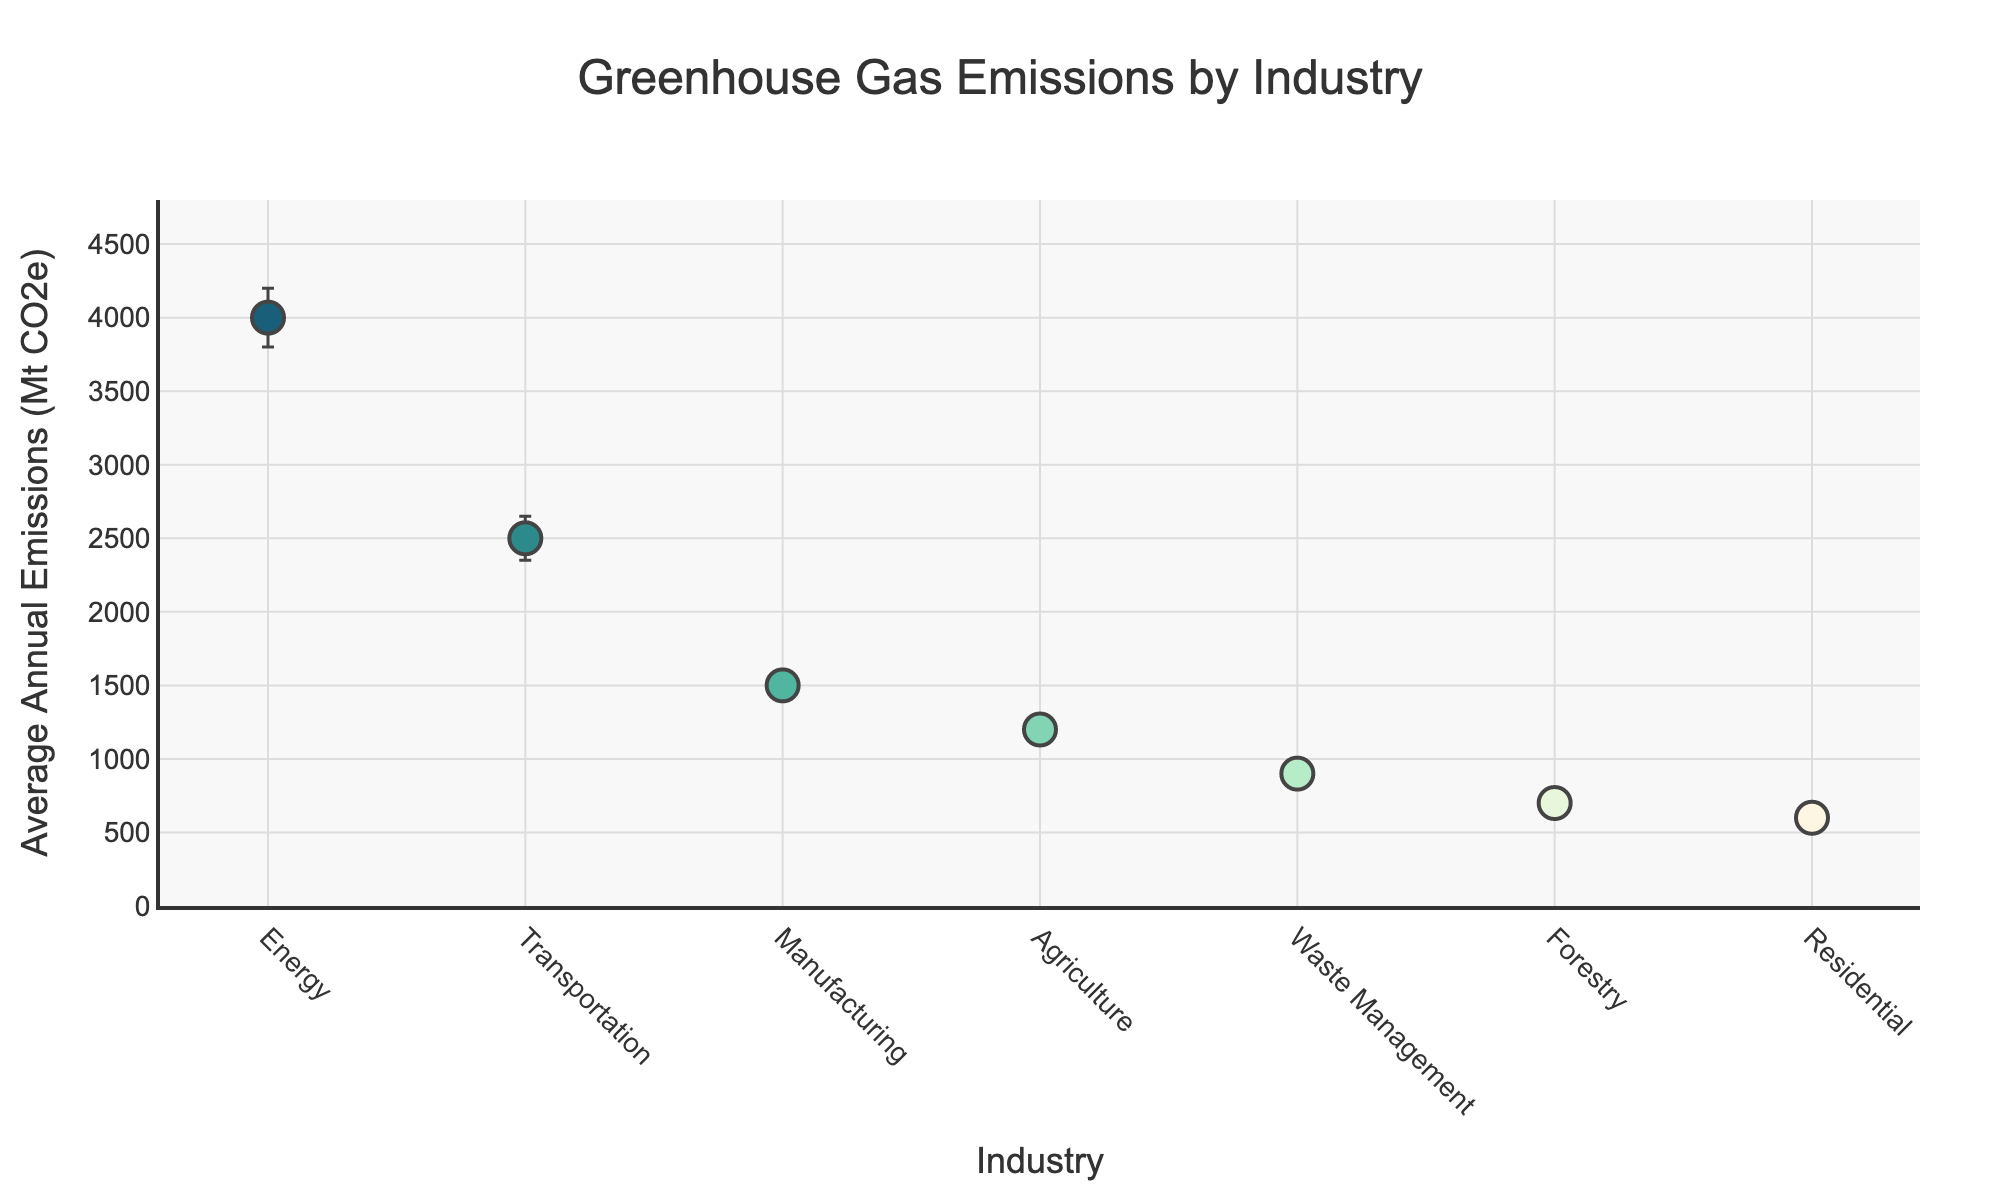What's the title of the figure? The title is displayed prominently at the top of the figure. It summarizes the main content of the plot.
Answer: Greenhouse Gas Emissions by Industry How many industries are represented in the figure? Each data point represents an industry. Counting the points displayed yields the total number of industries.
Answer: 7 Which industry has the highest average annual emissions? The y-axis represents average annual emissions, and the highest data point on this axis indicates the industry with the highest emissions.
Answer: Energy Which industry has the smallest annual fluctuation margin in emissions? The error bars indicate the fluctuation margins. The shortest error bar corresponds to the smallest fluctuation margin.
Answer: Residential What is the range of average annual emissions among the industries? The range is calculated by subtracting the smallest value from the largest value on the y-axis. The highest value is associated with Energy (4000 Mt CO2e) and the smallest with Residential (600 Mt CO2e).
Answer: 3400 Mt CO2e Among the industries listed, which one emits more than Agriculture but less than Transportation? Compare the y-values representing emissions. Find the industry falling between Agriculture (1200 Mt CO2e) and Transportation (2500 Mt CO2e).
Answer: Manufacturing What is the total average annual emission for all industries? Sum the average annual emissions of all industries: 4000 + 2500 + 1500 + 1200 + 900 + 700 + 600 = 11400 Mt CO2e.
Answer: 11400 Mt CO2e By how much do the average emissions from Waste Management exceed those from Forestry? The difference is found by subtracting Forestry's emissions (700 Mt CO2e) from Waste Management's emissions (900 Mt CO2e): 900 - 700.
Answer: 200 Mt CO2e What are the two industries with the closest average annual emissions? Compare the y-values of emissions to find the smallest difference. Agriculture (1200 Mt CO2e) and Manufacturing (1500 Mt CO2e) differ by 300 Mt CO2e.
Answer: Agriculture and Manufacturing 